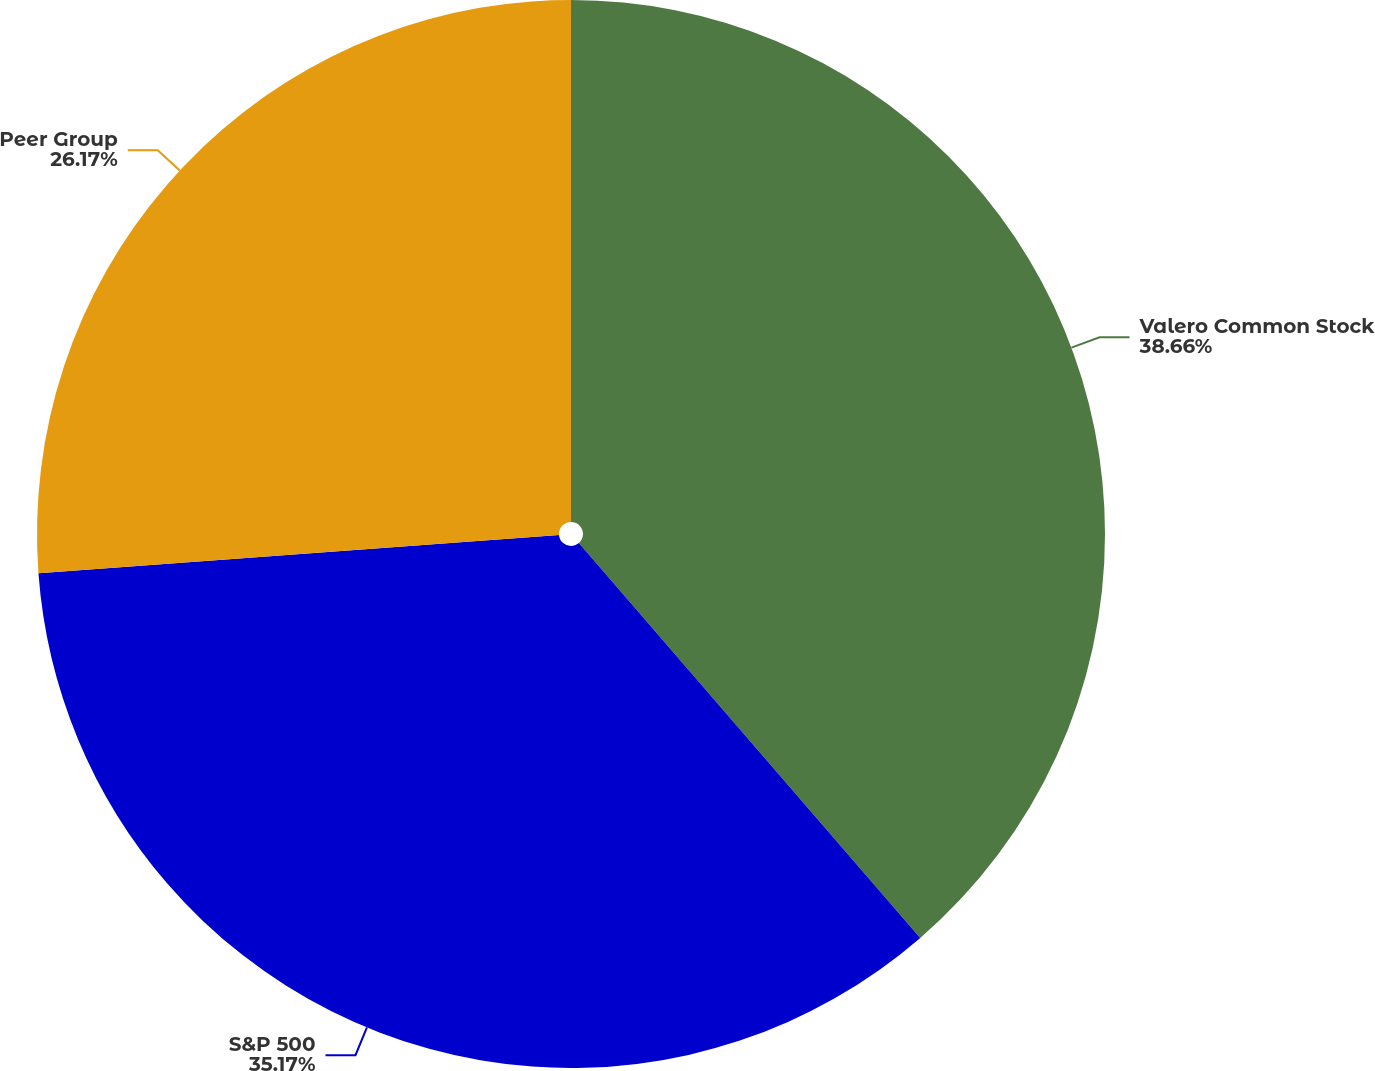Convert chart to OTSL. <chart><loc_0><loc_0><loc_500><loc_500><pie_chart><fcel>Valero Common Stock<fcel>S&P 500<fcel>Peer Group<nl><fcel>38.65%<fcel>35.17%<fcel>26.17%<nl></chart> 